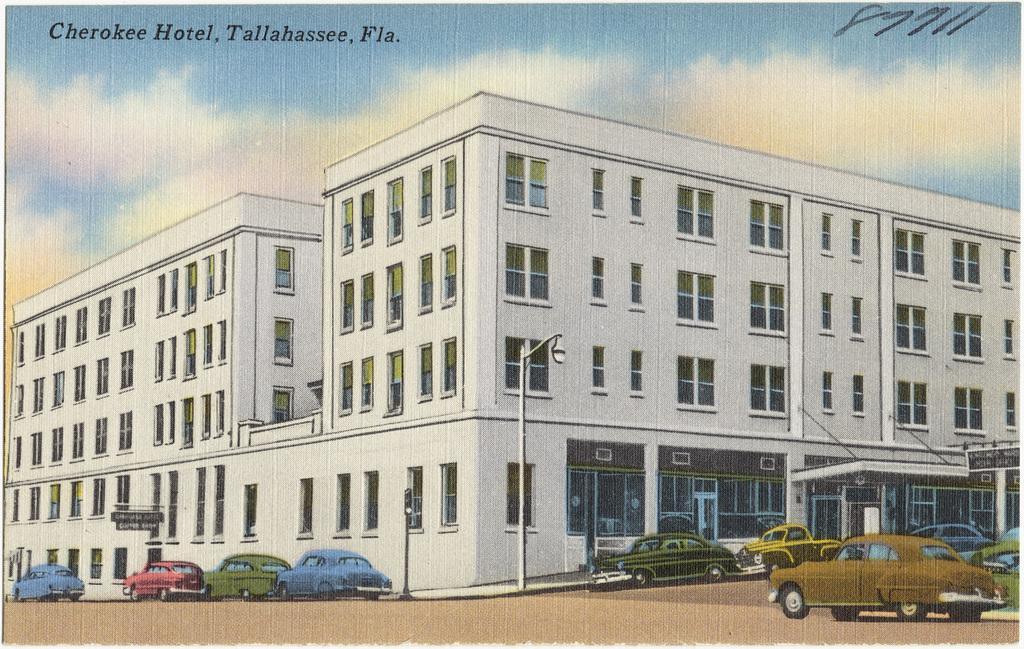In one or two sentences, can you explain what this image depicts? It is a graphical image. In the image we can see some vehicles, poles and building. Top of the image there are some clouds and sky and there is a water mark. 